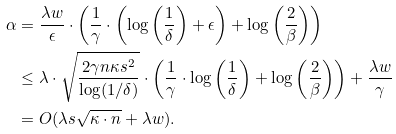<formula> <loc_0><loc_0><loc_500><loc_500>\alpha & = \frac { \lambda w } { \epsilon } \cdot \left ( \frac { 1 } { \gamma } \cdot \left ( \log \left ( \frac { 1 } { \delta } \right ) + \epsilon \right ) + \log \left ( \frac { 2 } { \beta } \right ) \right ) \\ & \leq \lambda \cdot \sqrt { \frac { 2 \gamma n \kappa s ^ { 2 } } { \log ( 1 / \delta ) } } \cdot \left ( \frac { 1 } { \gamma } \cdot \log \left ( \frac { 1 } { \delta } \right ) + \log \left ( \frac { 2 } { \beta } \right ) \right ) + \frac { \lambda w } { \gamma } \\ & = O ( \lambda s \sqrt { \kappa \cdot n } + \lambda w ) .</formula> 